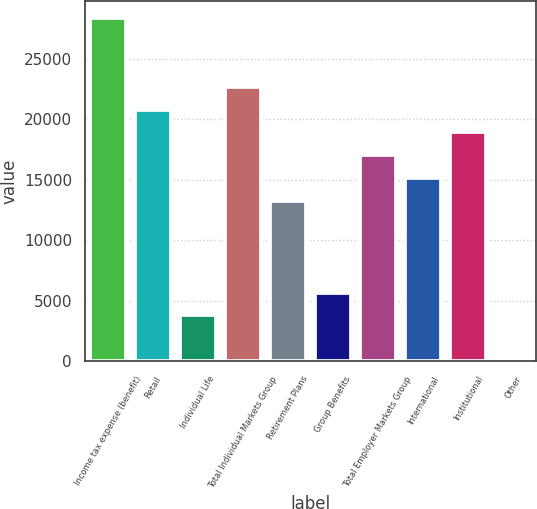Convert chart to OTSL. <chart><loc_0><loc_0><loc_500><loc_500><bar_chart><fcel>Income tax expense (benefit)<fcel>Retail<fcel>Individual Life<fcel>Total Individual Markets Group<fcel>Retirement Plans<fcel>Group Benefits<fcel>Total Employer Markets Group<fcel>International<fcel>Institutional<fcel>Other<nl><fcel>28348.5<fcel>20792.9<fcel>3792.8<fcel>22681.8<fcel>13237.3<fcel>5681.7<fcel>17015.1<fcel>15126.2<fcel>18904<fcel>15<nl></chart> 